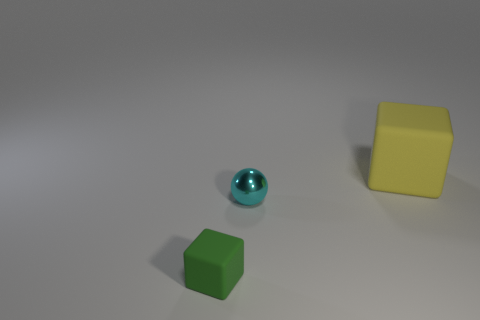Are there any other things that have the same material as the cyan object?
Keep it short and to the point. No. How big is the matte cube that is in front of the rubber thing on the right side of the cyan thing?
Give a very brief answer. Small. Are there any small blocks that have the same material as the large yellow block?
Your answer should be compact. Yes. Are there an equal number of big rubber objects to the left of the metallic ball and small shiny spheres on the right side of the green thing?
Ensure brevity in your answer.  No. What size is the rubber block that is left of the shiny thing?
Your answer should be very brief. Small. What material is the sphere that is on the left side of the rubber thing that is right of the tiny cube?
Offer a very short reply. Metal. There is a tiny object that is behind the thing in front of the small cyan metal ball; how many objects are behind it?
Give a very brief answer. 1. Do the small thing that is behind the green rubber object and the block to the right of the small matte object have the same material?
Your answer should be very brief. No. How many big yellow matte things have the same shape as the tiny rubber thing?
Provide a succinct answer. 1. Are there more things to the left of the tiny cyan sphere than green shiny spheres?
Offer a terse response. Yes. 